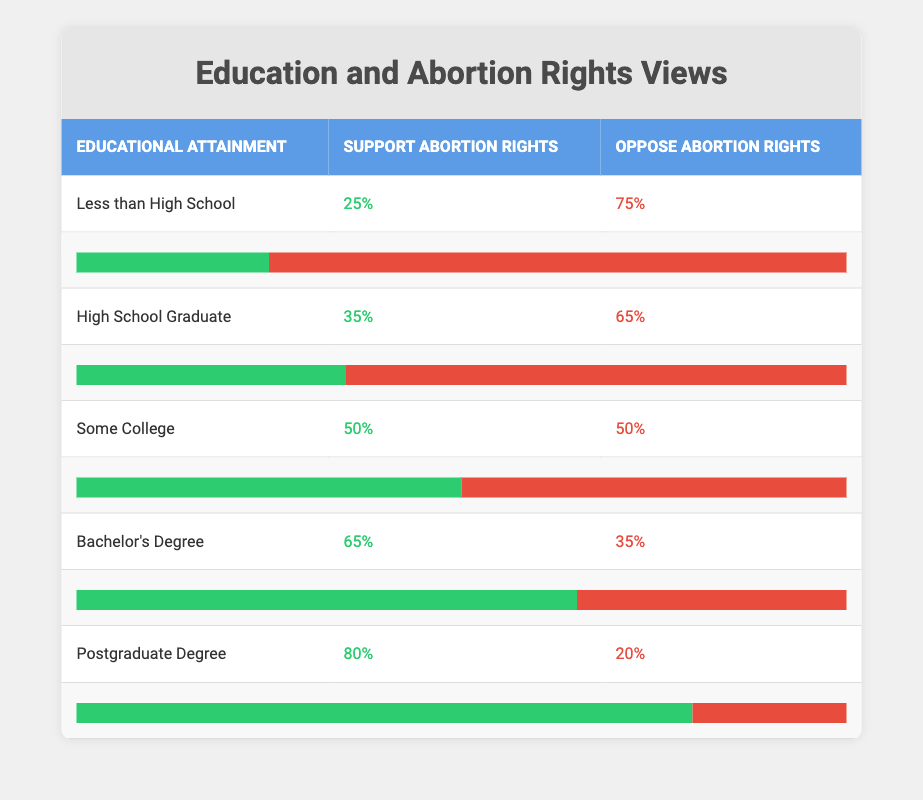What percentage of individuals with a Bachelor's Degree support abortion rights? The table indicates that 65% of individuals with a Bachelor's Degree support abortion rights.
Answer: 65% What is the percentage of people with less than a high school education who oppose abortion rights? According to the table, 75% of individuals with less than a high school education oppose abortion rights.
Answer: 75% Is it true that support for abortion rights increases with higher educational attainment? By examining the percentages in the table, we see that support for abortion rights indeed increases as educational attainment rises, from 25% for less than high school to 80% for postgraduate degrees.
Answer: Yes What is the difference in percentage between those who support abortion rights with a Postgraduate Degree and those who support it with a High School Graduate education? The table shows that 80% of those with a Postgraduate Degree support abortion rights, whereas 35% of High School Graduates do. The difference is 80 - 35 = 45%.
Answer: 45% If you were to calculate the average support for abortion rights across all educational attainment categories, what would it be? To find the average support, we sum the percentages of support (25 + 35 + 50 + 65 + 80 = 255) and divide by the number of categories (5). Therefore, the average is 255 / 5 = 51%.
Answer: 51% 